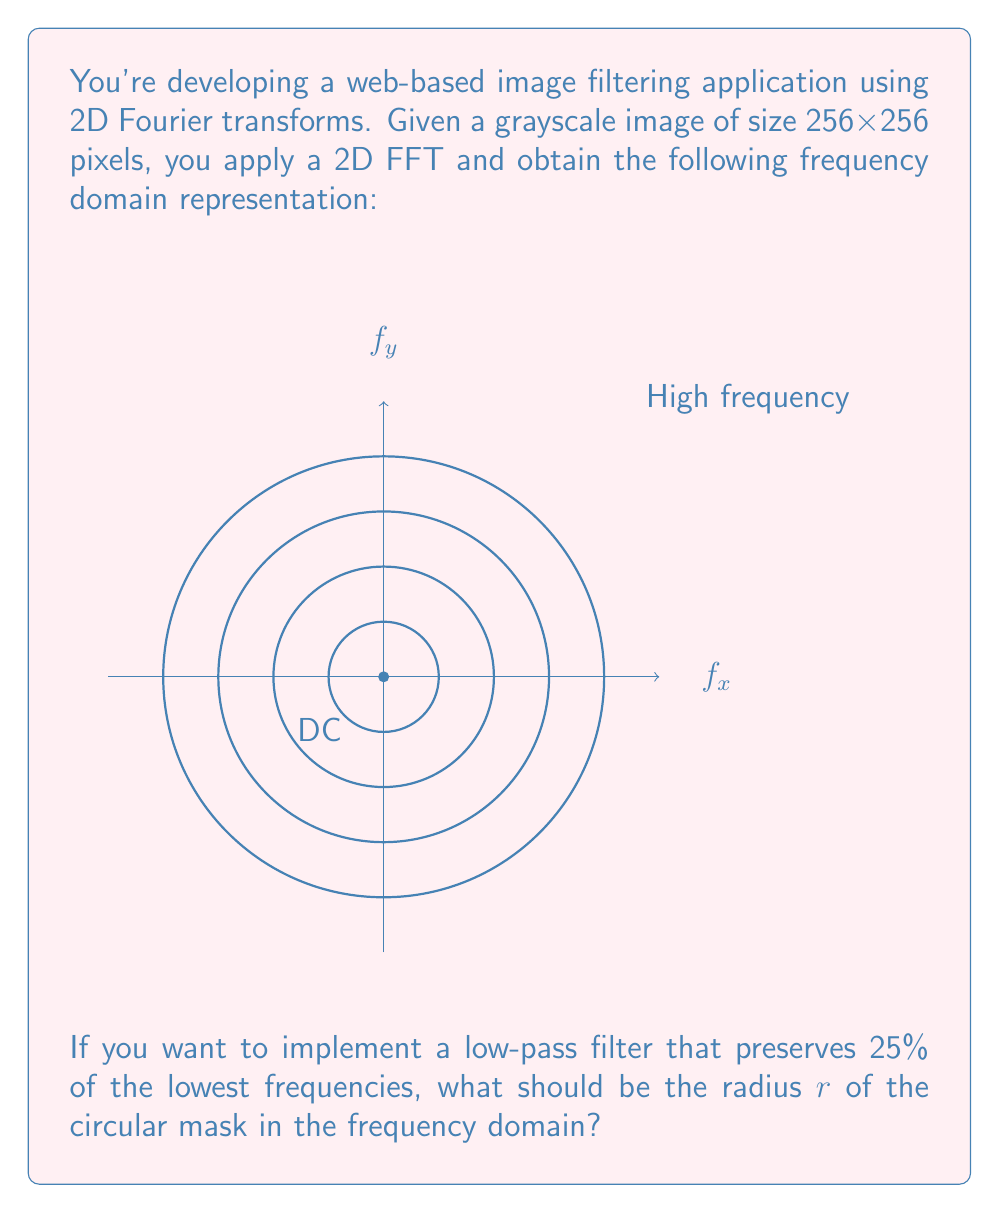Teach me how to tackle this problem. To solve this problem, we need to follow these steps:

1) In a 2D FFT of a square image, the low frequencies are concentrated at the center, while high frequencies are at the edges.

2) The total number of frequency components is equal to the number of pixels: 256 * 256 = 65,536.

3) We want to preserve 25% of the lowest frequencies, which means:
   $$0.25 * 65,536 = 16,384$$ frequency components.

4) In the frequency domain, these components form a circle. The area of this circle should be 16,384 pixels.

5) The area of a circle is given by $A = \pi r^2$. So we can set up the equation:
   $$\pi r^2 = 16,384$$

6) Solving for $r$:
   $$r^2 = 16,384 / \pi$$
   $$r = \sqrt{16,384 / \pi} \approx 72.25$$

7) Since we're dealing with pixels, we round this to the nearest integer: 72.

8) However, in a 256x256 image, the frequency domain is centered at (128,128). The radius we calculated is from this center point.

Therefore, the radius of the circular mask in the frequency domain should be 72 pixels from the center point (128,128).
Answer: 72 pixels 